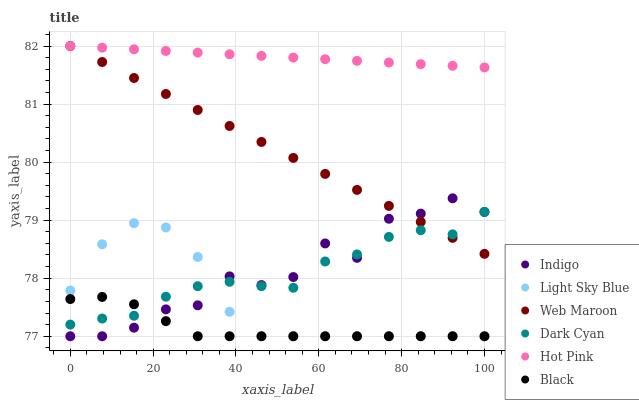Does Black have the minimum area under the curve?
Answer yes or no. Yes. Does Hot Pink have the maximum area under the curve?
Answer yes or no. Yes. Does Web Maroon have the minimum area under the curve?
Answer yes or no. No. Does Web Maroon have the maximum area under the curve?
Answer yes or no. No. Is Web Maroon the smoothest?
Answer yes or no. Yes. Is Indigo the roughest?
Answer yes or no. Yes. Is Hot Pink the smoothest?
Answer yes or no. No. Is Hot Pink the roughest?
Answer yes or no. No. Does Indigo have the lowest value?
Answer yes or no. Yes. Does Web Maroon have the lowest value?
Answer yes or no. No. Does Web Maroon have the highest value?
Answer yes or no. Yes. Does Light Sky Blue have the highest value?
Answer yes or no. No. Is Light Sky Blue less than Web Maroon?
Answer yes or no. Yes. Is Web Maroon greater than Black?
Answer yes or no. Yes. Does Web Maroon intersect Hot Pink?
Answer yes or no. Yes. Is Web Maroon less than Hot Pink?
Answer yes or no. No. Is Web Maroon greater than Hot Pink?
Answer yes or no. No. Does Light Sky Blue intersect Web Maroon?
Answer yes or no. No. 